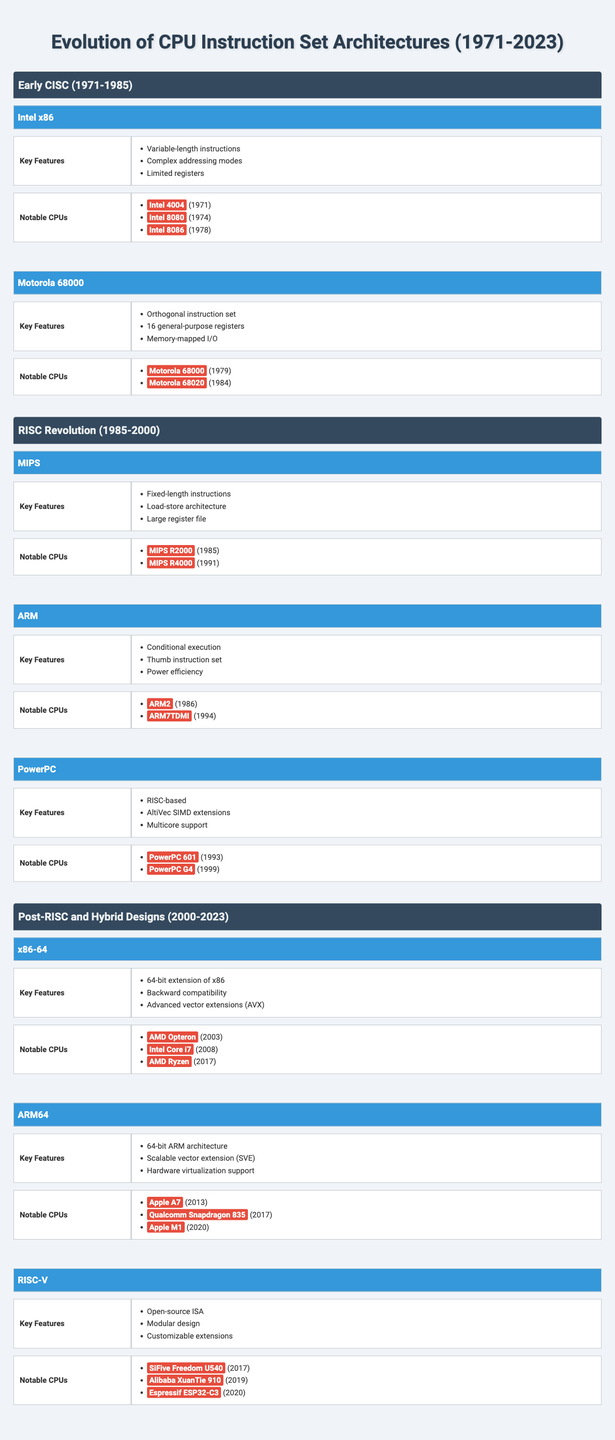What are the notable CPUs of the Intel x86 architecture? Under the "Early CISC (1971-1985)" era, the Intel x86 architecture is listed with notable CPUs: Intel 4004 (1971), Intel 8080 (1974), and Intel 8086 (1978).
Answer: Intel 4004, Intel 8080, Intel 8086 Which architecture was first introduced in the RISC Revolution era? Looking at the "RISC Revolution (1985-2000)" era, the first architecture listed is MIPS, introduced with the MIPS R2000 in 1985.
Answer: MIPS Does the ARM architecture include any features related to efficiency? The ARM architecture in the table specifies "Power efficiency" as one of its key features. Thus, this fact is true.
Answer: Yes How many CPUs are notable for the ARM architecture? Reviewing the "ARM" architecture entry, it lists three notable CPUs: ARM2 (1986), ARM7TDMI (1994), and others. Therefore, the total is three.
Answer: 3 Which architecture includes advanced vector extensions among its features? Checking the "Post-RISC and Hybrid Designs (2000-2023)" era, the x86-64 architecture is noted for its "Advanced vector extensions (AVX)."
Answer: x86-64 Is the PowerPC architecture RISC-based? The table states that PowerPC is "RISC-based," confirming that this fact is accurate.
Answer: Yes How do the number of notable CPUs for x86-64 and RISC-V compare? The x86-64 architecture has three notable CPUs: AMD Opteron (2003), Intel Core i7 (2008), AMD Ryzen (2017). The RISC-V architecture has three notable CPUs: SiFive Freedom U540 (2017), Alibaba XuanTie 910 (2019), and Espressif ESP32-C3 (2020). Both have the same number of notable CPUs.
Answer: They are equal What are the key features of the Motorola 68000 architecture? The "Motorola 68000" architecture lists three key features: "Orthogonal instruction set," "16 general-purpose registers," and "Memory-mapped I/O."
Answer: Orthogonal instruction set, 16 registers, Memory-mapped I/O Which architecture has the highest number of notable CPUs listed in the table? By examining each architecture's notable CPUs, both Intel x86 and ARM have three notable CPUs, while others may have less. Thus, they share the highest count.
Answer: x86, ARM Identify the era during which the ARM2 CPU was released? The ARM2 CPU is mentioned under the ARM architecture, which is associated with the "RISC Revolution (1985-2000)" era, where it was first released in 1986.
Answer: RISC Revolution (1985-2000) 